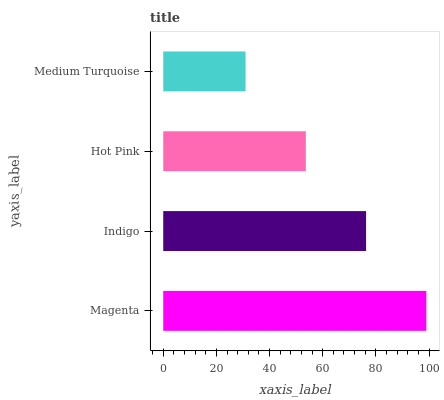Is Medium Turquoise the minimum?
Answer yes or no. Yes. Is Magenta the maximum?
Answer yes or no. Yes. Is Indigo the minimum?
Answer yes or no. No. Is Indigo the maximum?
Answer yes or no. No. Is Magenta greater than Indigo?
Answer yes or no. Yes. Is Indigo less than Magenta?
Answer yes or no. Yes. Is Indigo greater than Magenta?
Answer yes or no. No. Is Magenta less than Indigo?
Answer yes or no. No. Is Indigo the high median?
Answer yes or no. Yes. Is Hot Pink the low median?
Answer yes or no. Yes. Is Medium Turquoise the high median?
Answer yes or no. No. Is Magenta the low median?
Answer yes or no. No. 